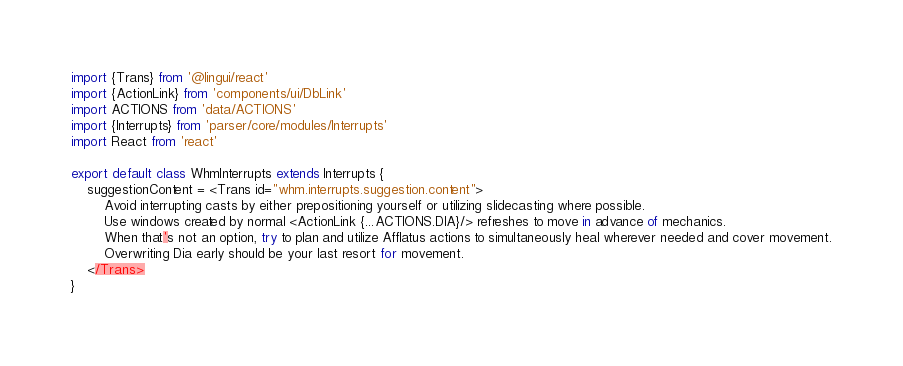Convert code to text. <code><loc_0><loc_0><loc_500><loc_500><_JavaScript_>import {Trans} from '@lingui/react'
import {ActionLink} from 'components/ui/DbLink'
import ACTIONS from 'data/ACTIONS'
import {Interrupts} from 'parser/core/modules/Interrupts'
import React from 'react'

export default class WhmInterrupts extends Interrupts {
	suggestionContent = <Trans id="whm.interrupts.suggestion.content">
		Avoid interrupting casts by either prepositioning yourself or utilizing slidecasting where possible.
		Use windows created by normal <ActionLink {...ACTIONS.DIA}/> refreshes to move in advance of mechanics.
		When that's not an option, try to plan and utilize Afflatus actions to simultaneously heal wherever needed and cover movement.
		Overwriting Dia early should be your last resort for movement.
	</Trans>
}
</code> 